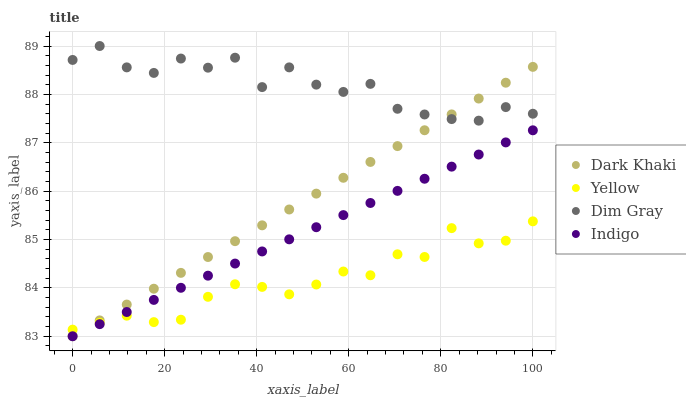Does Yellow have the minimum area under the curve?
Answer yes or no. Yes. Does Dim Gray have the maximum area under the curve?
Answer yes or no. Yes. Does Indigo have the minimum area under the curve?
Answer yes or no. No. Does Indigo have the maximum area under the curve?
Answer yes or no. No. Is Indigo the smoothest?
Answer yes or no. Yes. Is Dim Gray the roughest?
Answer yes or no. Yes. Is Dim Gray the smoothest?
Answer yes or no. No. Is Indigo the roughest?
Answer yes or no. No. Does Dark Khaki have the lowest value?
Answer yes or no. Yes. Does Dim Gray have the lowest value?
Answer yes or no. No. Does Dim Gray have the highest value?
Answer yes or no. Yes. Does Indigo have the highest value?
Answer yes or no. No. Is Indigo less than Dim Gray?
Answer yes or no. Yes. Is Dim Gray greater than Yellow?
Answer yes or no. Yes. Does Dark Khaki intersect Dim Gray?
Answer yes or no. Yes. Is Dark Khaki less than Dim Gray?
Answer yes or no. No. Is Dark Khaki greater than Dim Gray?
Answer yes or no. No. Does Indigo intersect Dim Gray?
Answer yes or no. No. 